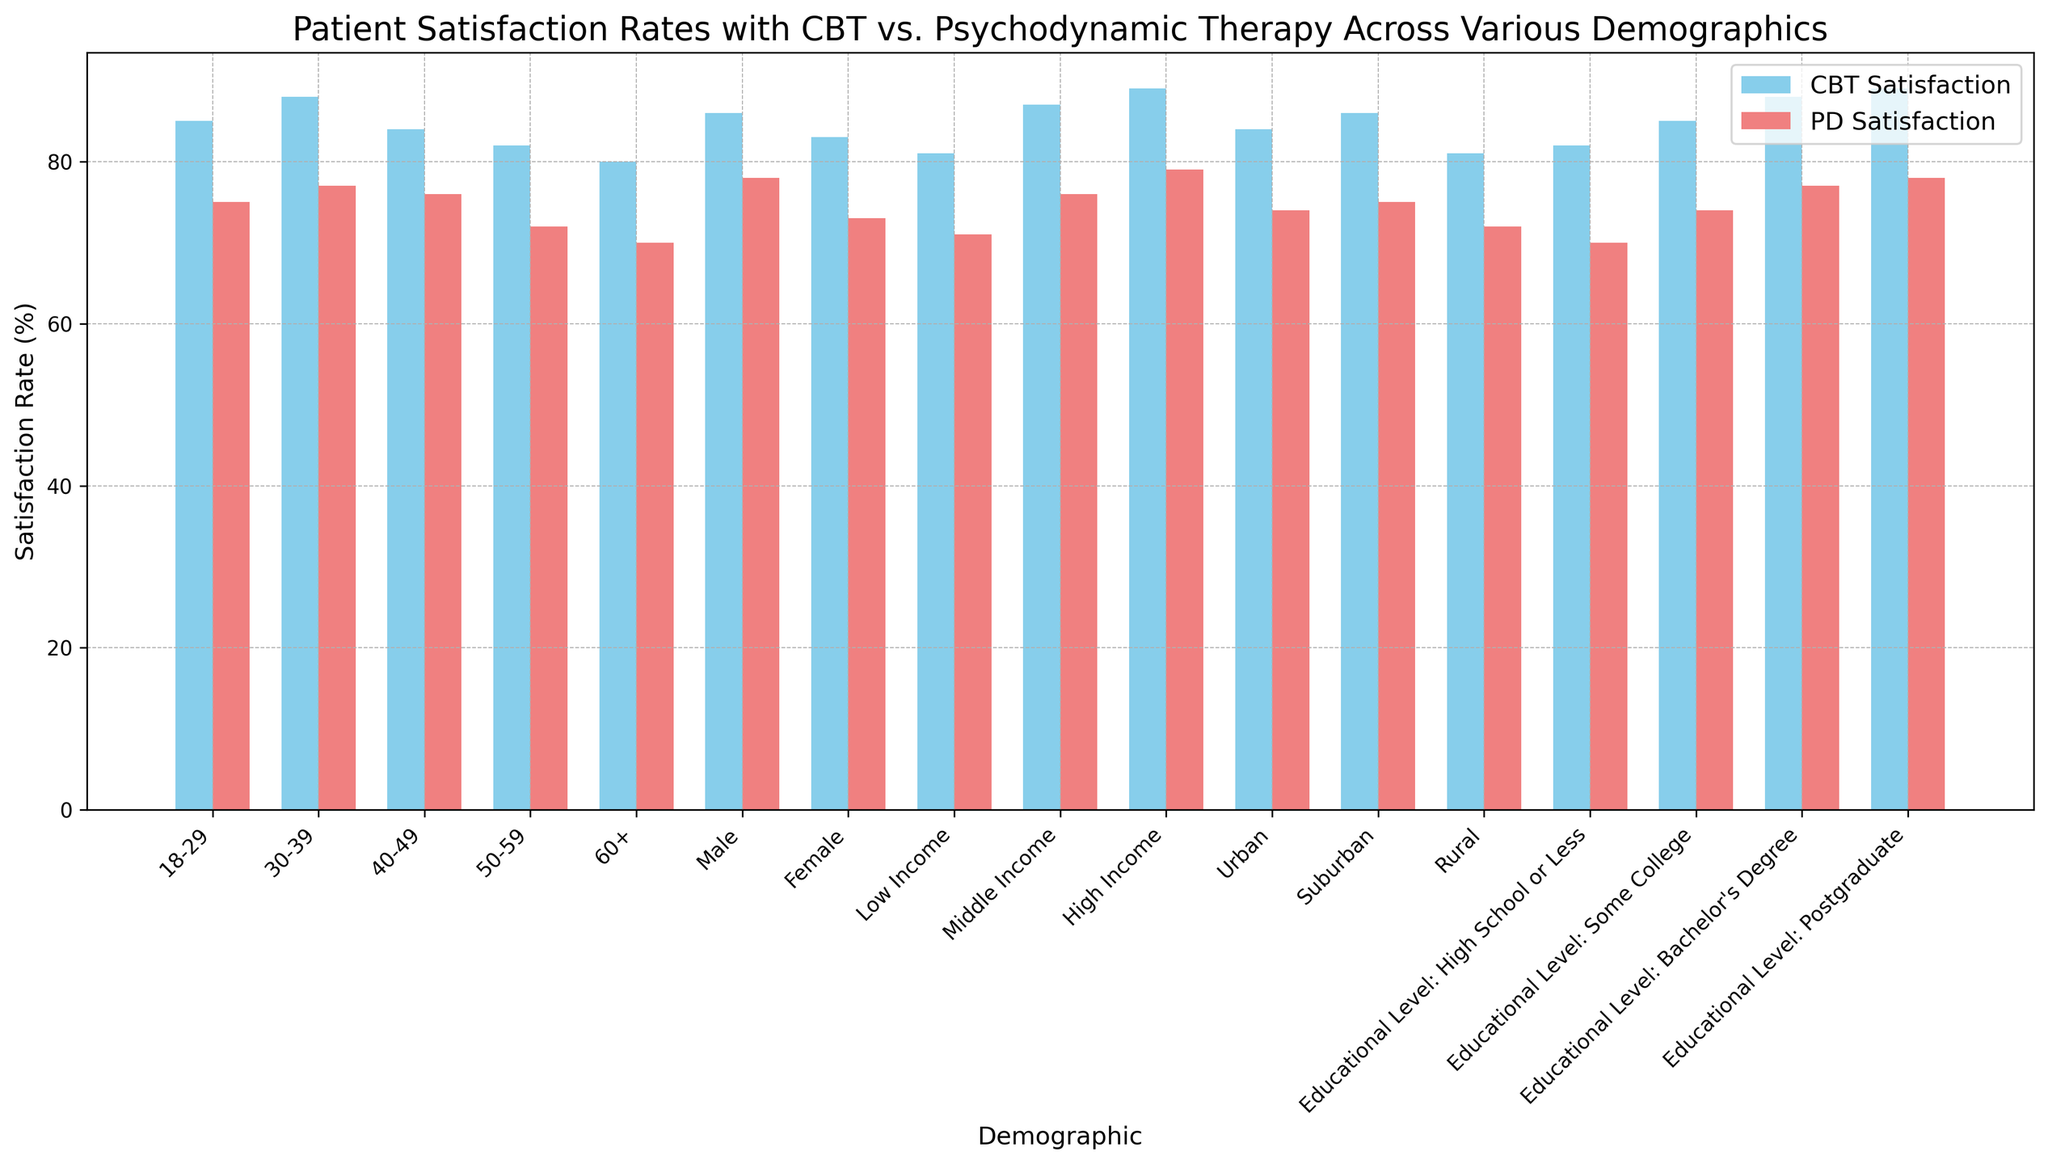What's the overall trend in satisfaction rates with age for CBT compared to PD? By observing the graph, we can see the satisfaction rates for each age group listed from '18-29' to '60+'. CBT satisfaction rates start at 85% for the youngest group and gradually decline to 80% for the oldest group. PD satisfaction rates start at 75% and also decline steadily to 70%. Both therapies show a decrease in satisfaction with age, but CBT consistently has higher satisfaction rates than PD within each age group.
Answer: CBT shows higher satisfaction rates than PD across all age groups, with both declining as age increases Which gender has a higher satisfaction rate for CBT? The figure shows two bars for gender, one for males and one for females. The bar for males (86%) is higher than the bar for females (83%) for CBT satisfaction.
Answer: Male For which income group is the difference in satisfaction between CBT and PD the largest? Observing the figure, we see the satisfaction rates for low, middle, and high-income groups. The differences between CBT and PD are: Low Income (81% - 71% = 10%), Middle Income (87% - 76% = 11%), High Income (89% - 79% = 10%). The largest difference is in the Middle Income group.
Answer: Middle Income What is the average satisfaction rate with CBT across different educational levels? The given educational levels are 'High School or Less' (82%), 'Some College' (85%), 'Bachelor's Degree' (88%), and 'Postgraduate' (89%). Summing these rates and dividing by 4 gives the average: (82 + 85 + 88 + 89) / 4 = 344 / 4 = 86%.
Answer: 86% How do satisfaction rates compare between urban, suburban, and rural areas for PD? By examining the bars for the 'Urban', 'Suburban', and 'Rural' demographics, we find their PD satisfaction rates are 74%, 75%, and 72% respectively. Suburban has slightly higher rates than Urban and both are higher than Rural.
Answer: Suburban > Urban > Rural What is the difference in satisfaction rate for CBT between males and females? The bars for CBT satisfaction show 86% for males and 83% for females. The difference is 86% - 83% = 3%.
Answer: 3% Which demographic has the highest satisfaction rate for CBT? Reviewing all demographics, the highest satisfaction rate for CBT is in the 'High Income' and 'Postgraduate' groups, both at 89%.
Answer: High Income and Postgraduate What is the average satisfaction rate with PD across all demographics? Summing the PD satisfaction rates across all demographics (75, 77, 76, 72, 70, 78, 73, 71, 76, 79, 74, 75, 72, 70, 74, 77, 78) and dividing by the number of demographics (17), we get: (1233 / 17) ≈ 72.5%.
Answer: 72.5% Between which two consecutive age groups is the satisfaction rate with CBT most similar? Comparing the satisfaction rates for consecutive age groups: '18-29' (85%) and '30-39' (88%) have a difference of 3%, '30-39' (88%) and '40-49' (84%) have 4%, '40-49' (84%) and '50-59' (82%) have 2%, '50-59' (82%) and '60+' (80%) have 2%. The smallest differences are between '40-49' and '50-59' and between '50-59' and '60+'.
Answer: '40-49' and '50-59', '50-59' and '60+' What's the difference in satisfaction rates between the lowest and highest satisfaction demographics for PD? The lowest satisfaction rate for PD is 'Educational Level: High School or Less' at 70%, and the highest is 'High Income' at 79%. The difference is 79% - 70% = 9%.
Answer: 9% 